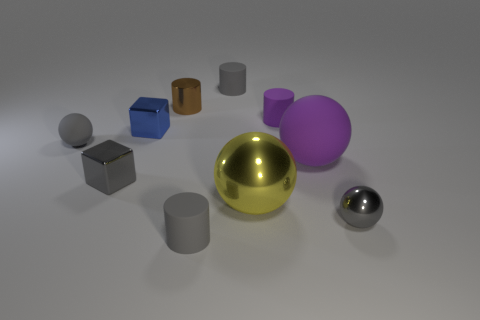Subtract all rubber cylinders. How many cylinders are left? 1 Subtract all gray balls. How many balls are left? 2 Subtract all spheres. How many objects are left? 6 Subtract all green blocks. How many brown cylinders are left? 1 Add 3 brown metal cylinders. How many brown metal cylinders are left? 4 Add 3 gray things. How many gray things exist? 8 Subtract 0 cyan balls. How many objects are left? 10 Subtract 1 blocks. How many blocks are left? 1 Subtract all purple spheres. Subtract all cyan cubes. How many spheres are left? 3 Subtract all small objects. Subtract all large objects. How many objects are left? 0 